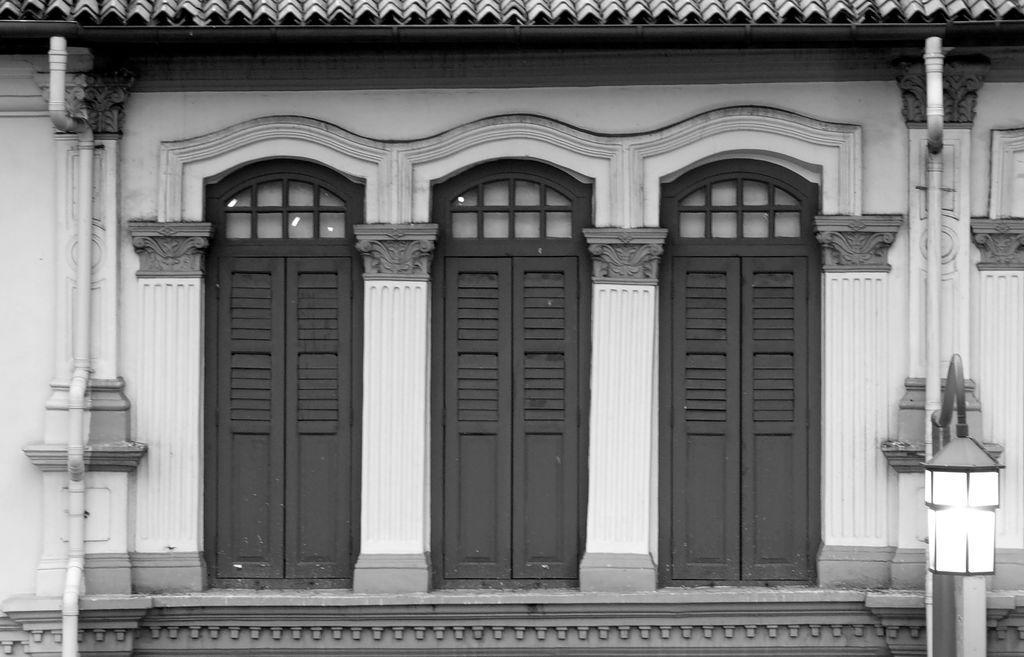Please provide a concise description of this image. In this image we can see the building with pipelines, pillars, windows, electric lights and walls. 